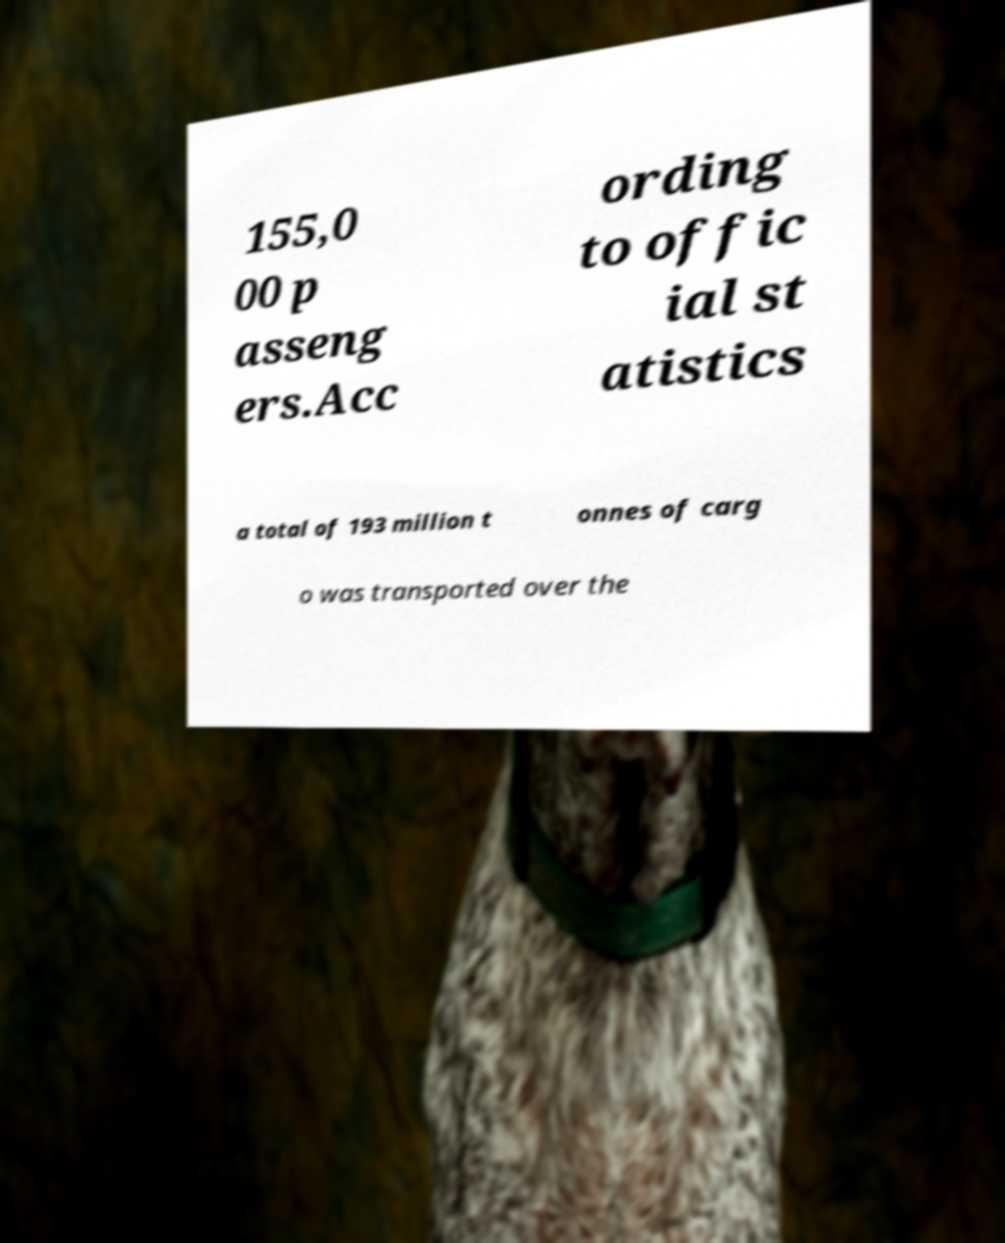What messages or text are displayed in this image? I need them in a readable, typed format. 155,0 00 p asseng ers.Acc ording to offic ial st atistics a total of 193 million t onnes of carg o was transported over the 